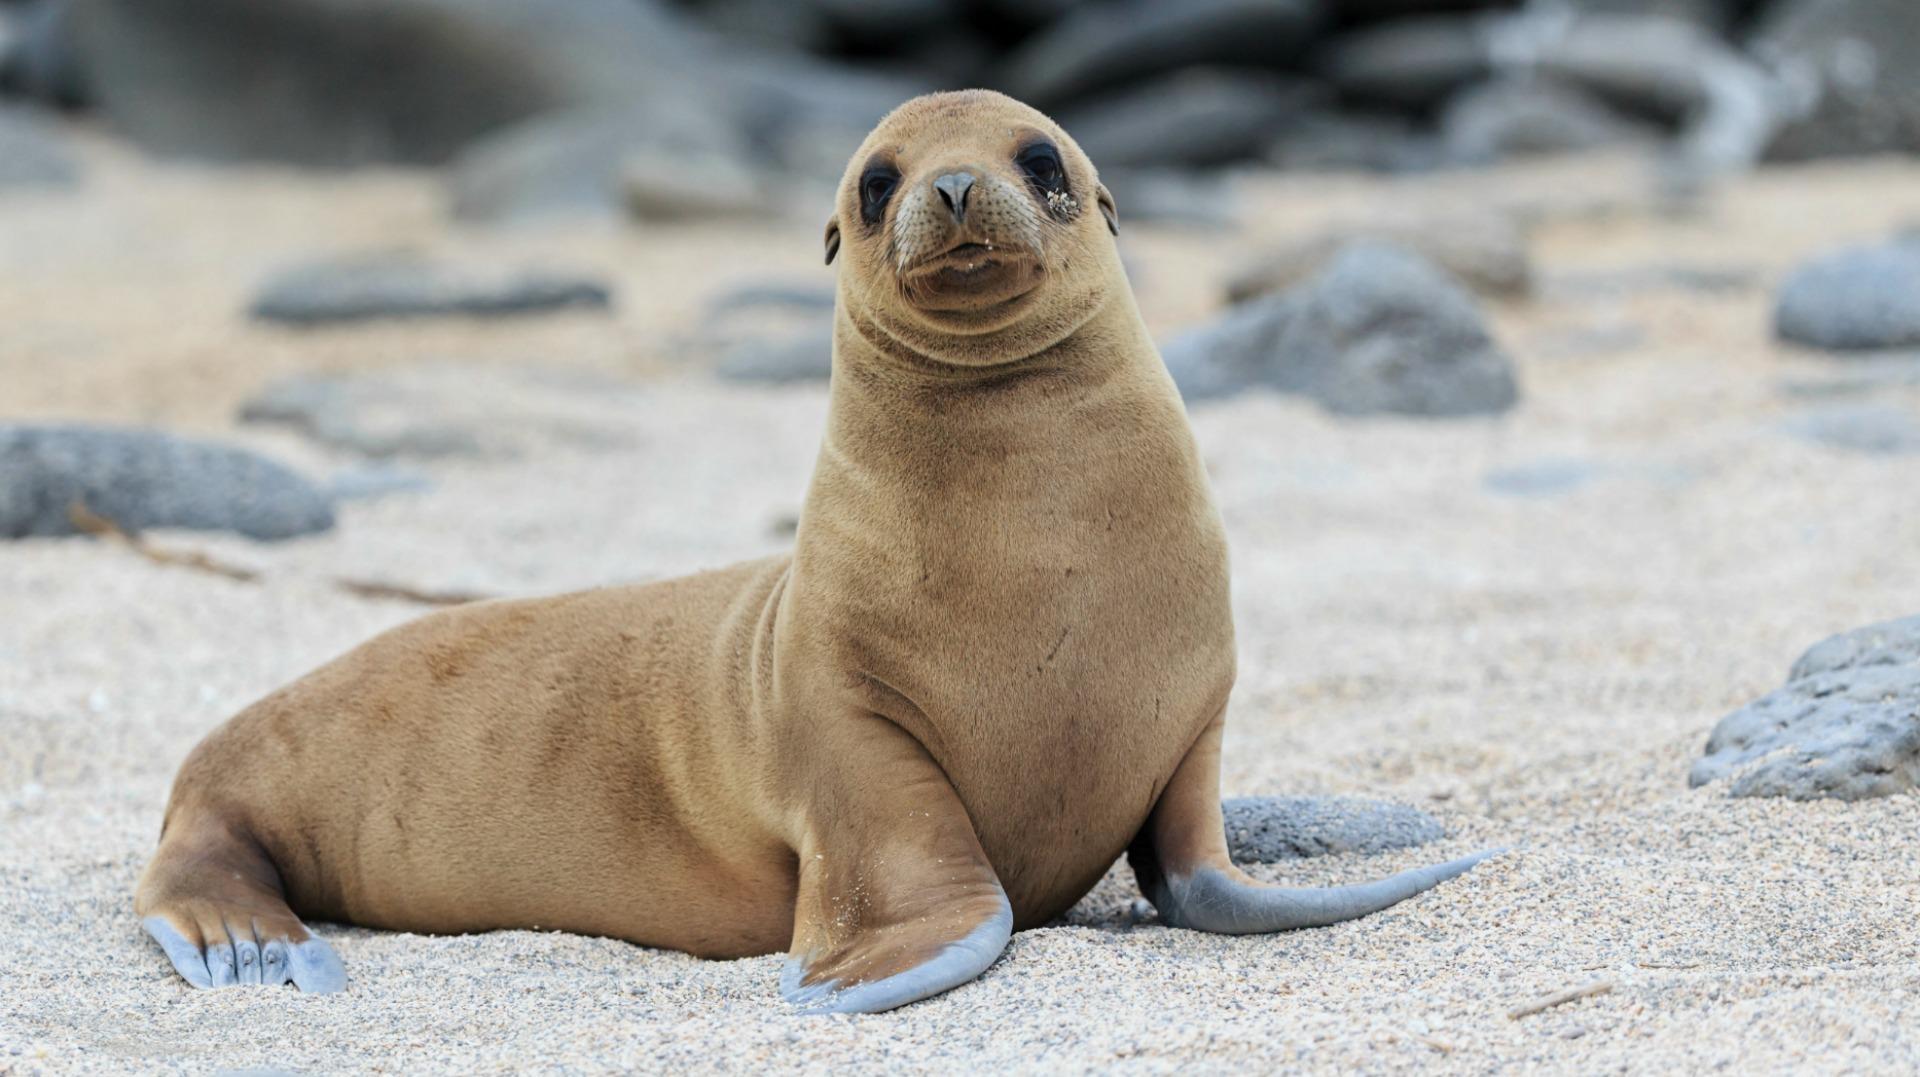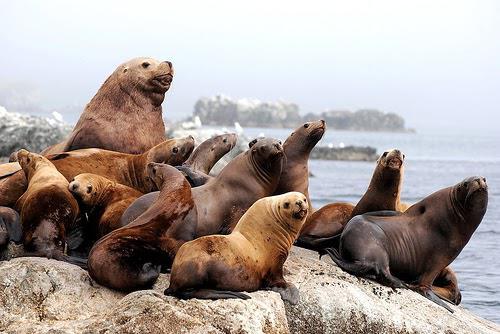The first image is the image on the left, the second image is the image on the right. Assess this claim about the two images: "No image shows more than two seals.". Correct or not? Answer yes or no. No. 